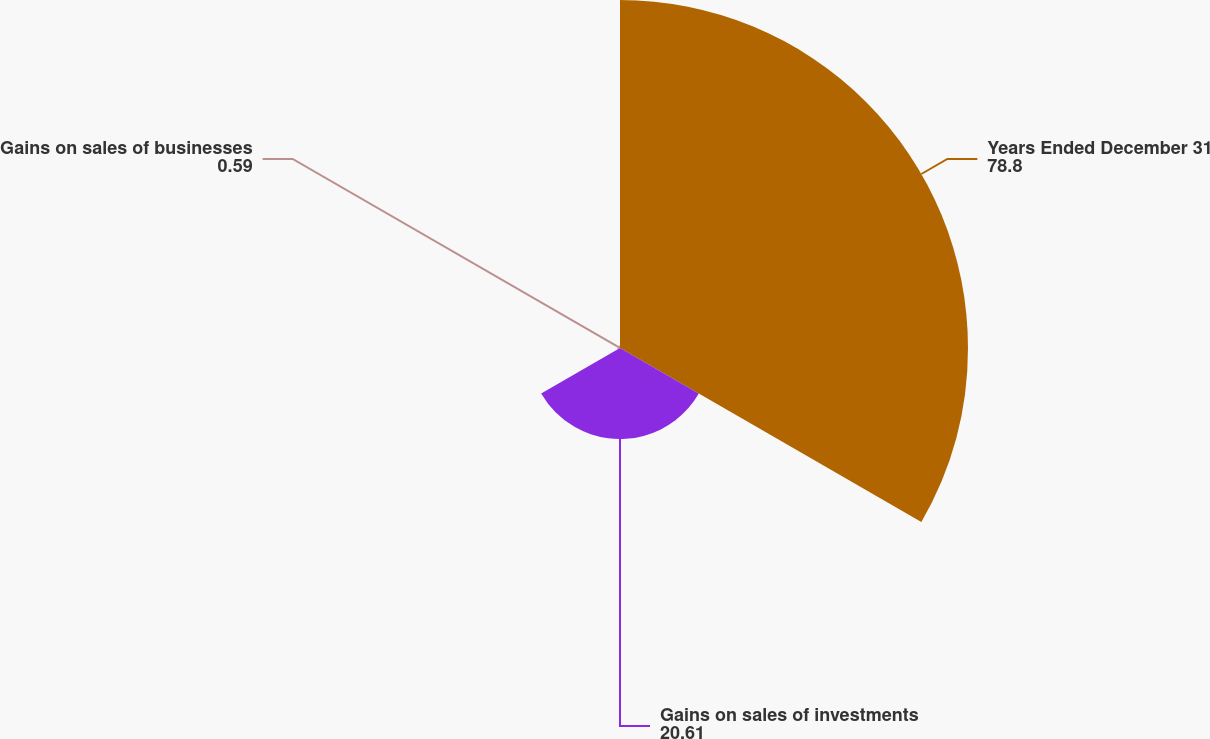Convert chart to OTSL. <chart><loc_0><loc_0><loc_500><loc_500><pie_chart><fcel>Years Ended December 31<fcel>Gains on sales of investments<fcel>Gains on sales of businesses<nl><fcel>78.8%<fcel>20.61%<fcel>0.59%<nl></chart> 